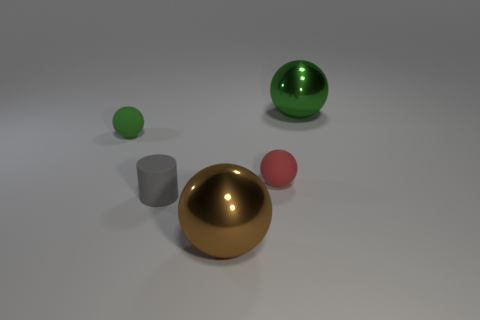Add 1 balls. How many objects exist? 6 Subtract all big brown spheres. How many spheres are left? 3 Subtract 1 cylinders. How many cylinders are left? 0 Subtract all gray blocks. How many blue cylinders are left? 0 Subtract all brown balls. How many balls are left? 3 Subtract all balls. How many objects are left? 1 Subtract all green cylinders. Subtract all red balls. How many cylinders are left? 1 Subtract all green rubber blocks. Subtract all big brown balls. How many objects are left? 4 Add 3 brown things. How many brown things are left? 4 Add 2 brown metallic objects. How many brown metallic objects exist? 3 